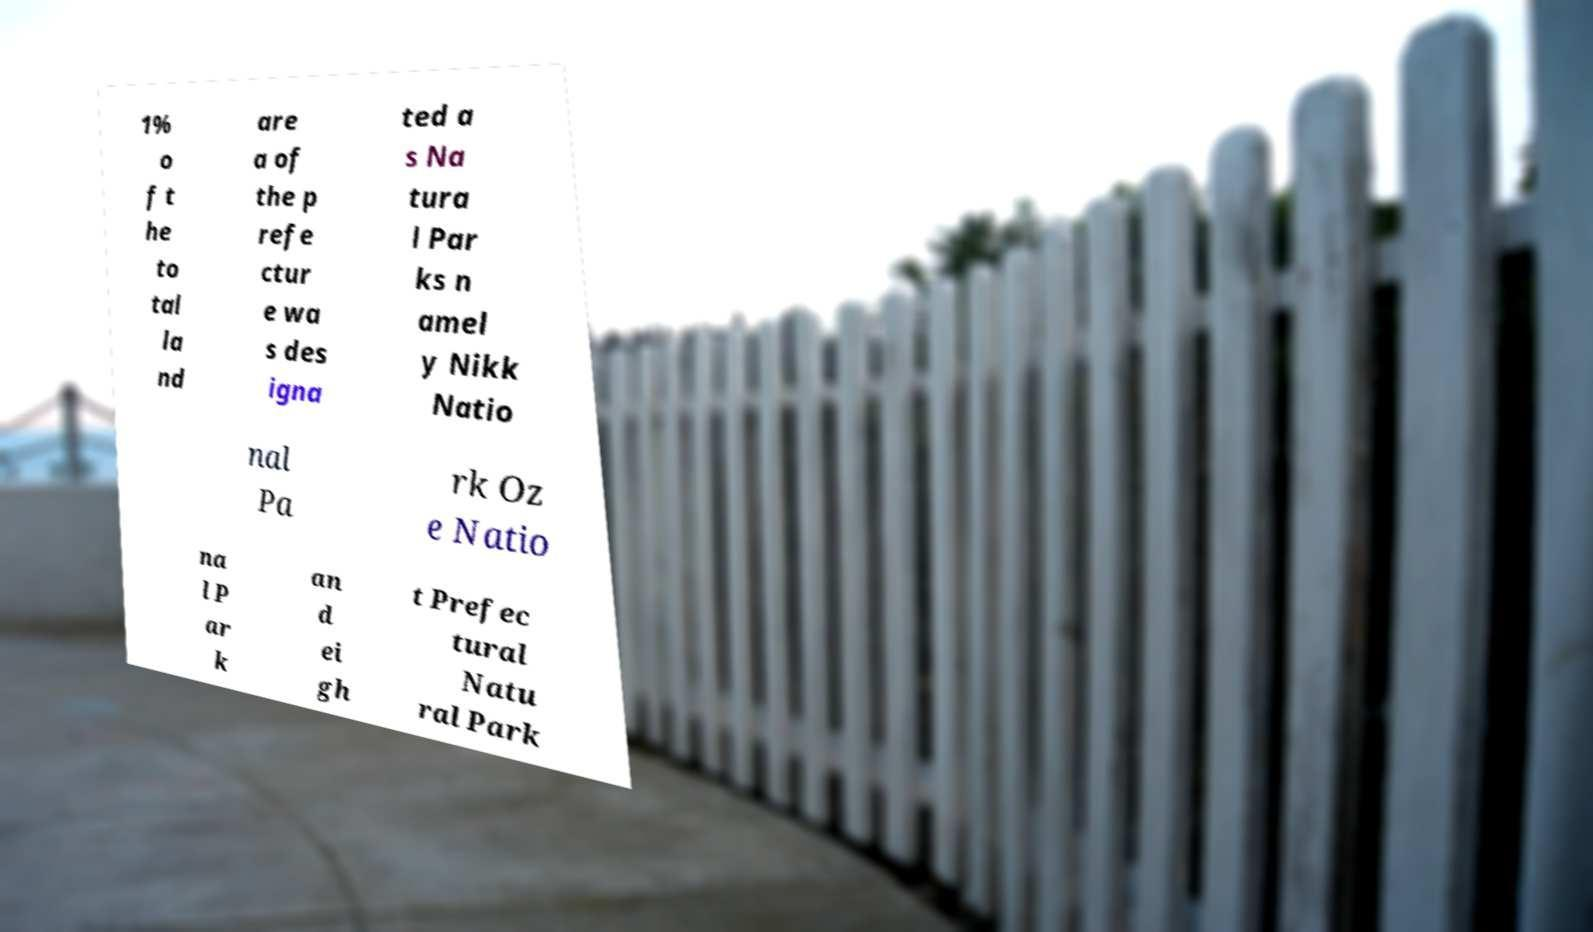Can you read and provide the text displayed in the image?This photo seems to have some interesting text. Can you extract and type it out for me? 1% o f t he to tal la nd are a of the p refe ctur e wa s des igna ted a s Na tura l Par ks n amel y Nikk Natio nal Pa rk Oz e Natio na l P ar k an d ei gh t Prefec tural Natu ral Park 